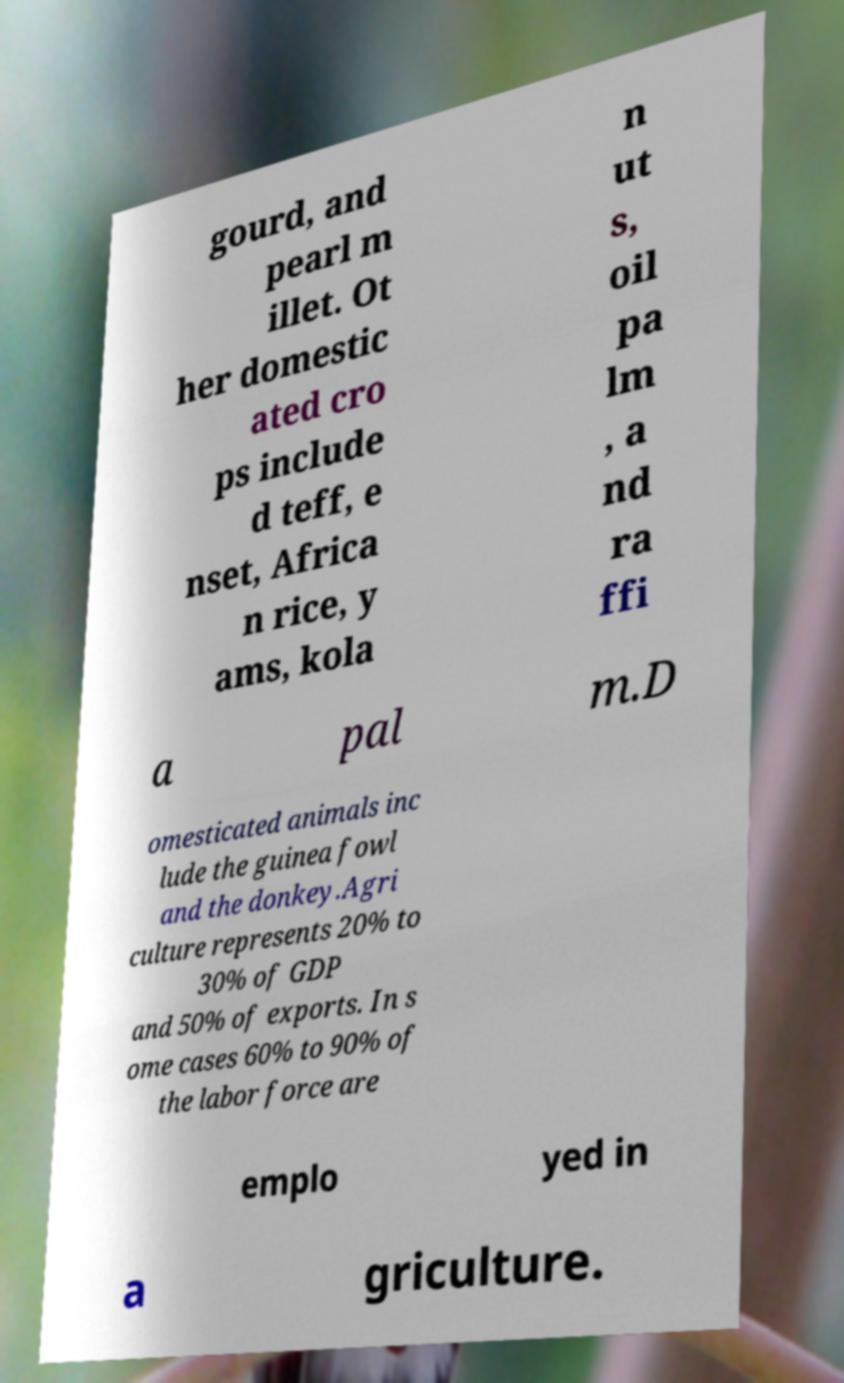For documentation purposes, I need the text within this image transcribed. Could you provide that? gourd, and pearl m illet. Ot her domestic ated cro ps include d teff, e nset, Africa n rice, y ams, kola n ut s, oil pa lm , a nd ra ffi a pal m.D omesticated animals inc lude the guinea fowl and the donkey.Agri culture represents 20% to 30% of GDP and 50% of exports. In s ome cases 60% to 90% of the labor force are emplo yed in a griculture. 